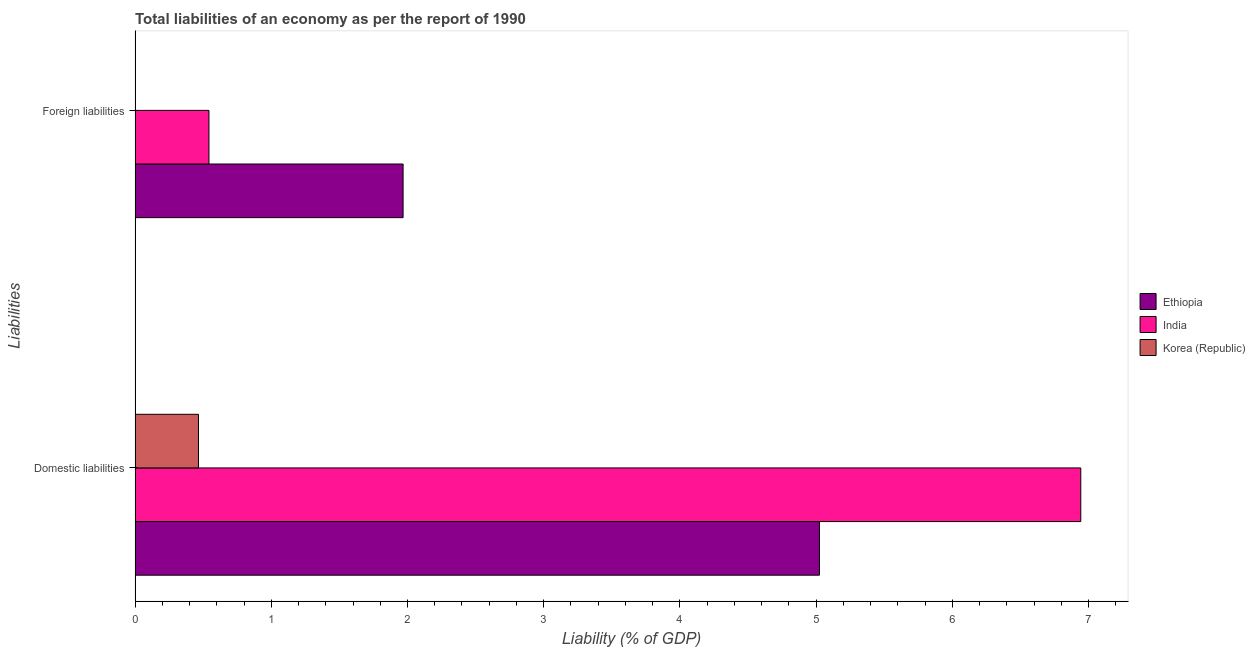How many different coloured bars are there?
Ensure brevity in your answer.  3. Are the number of bars per tick equal to the number of legend labels?
Provide a short and direct response. No. How many bars are there on the 2nd tick from the top?
Ensure brevity in your answer.  3. What is the label of the 1st group of bars from the top?
Keep it short and to the point. Foreign liabilities. What is the incurrence of domestic liabilities in Ethiopia?
Provide a succinct answer. 5.02. Across all countries, what is the maximum incurrence of foreign liabilities?
Make the answer very short. 1.97. In which country was the incurrence of foreign liabilities maximum?
Provide a succinct answer. Ethiopia. What is the total incurrence of domestic liabilities in the graph?
Provide a succinct answer. 12.43. What is the difference between the incurrence of domestic liabilities in Korea (Republic) and that in Ethiopia?
Your answer should be very brief. -4.56. What is the difference between the incurrence of foreign liabilities in Ethiopia and the incurrence of domestic liabilities in Korea (Republic)?
Offer a very short reply. 1.5. What is the average incurrence of domestic liabilities per country?
Ensure brevity in your answer.  4.14. What is the difference between the incurrence of foreign liabilities and incurrence of domestic liabilities in Ethiopia?
Give a very brief answer. -3.06. In how many countries, is the incurrence of domestic liabilities greater than 5.6 %?
Your answer should be very brief. 1. What is the ratio of the incurrence of domestic liabilities in Ethiopia to that in India?
Your answer should be compact. 0.72. How many bars are there?
Make the answer very short. 5. What is the difference between two consecutive major ticks on the X-axis?
Make the answer very short. 1. Are the values on the major ticks of X-axis written in scientific E-notation?
Give a very brief answer. No. Does the graph contain any zero values?
Provide a succinct answer. Yes. Where does the legend appear in the graph?
Ensure brevity in your answer.  Center right. How many legend labels are there?
Offer a very short reply. 3. How are the legend labels stacked?
Give a very brief answer. Vertical. What is the title of the graph?
Provide a short and direct response. Total liabilities of an economy as per the report of 1990. Does "New Caledonia" appear as one of the legend labels in the graph?
Offer a terse response. No. What is the label or title of the X-axis?
Keep it short and to the point. Liability (% of GDP). What is the label or title of the Y-axis?
Provide a succinct answer. Liabilities. What is the Liability (% of GDP) in Ethiopia in Domestic liabilities?
Provide a succinct answer. 5.02. What is the Liability (% of GDP) of India in Domestic liabilities?
Provide a short and direct response. 6.94. What is the Liability (% of GDP) in Korea (Republic) in Domestic liabilities?
Provide a succinct answer. 0.47. What is the Liability (% of GDP) in Ethiopia in Foreign liabilities?
Provide a short and direct response. 1.97. What is the Liability (% of GDP) of India in Foreign liabilities?
Give a very brief answer. 0.54. What is the Liability (% of GDP) in Korea (Republic) in Foreign liabilities?
Offer a very short reply. 0. Across all Liabilities, what is the maximum Liability (% of GDP) of Ethiopia?
Your answer should be compact. 5.02. Across all Liabilities, what is the maximum Liability (% of GDP) in India?
Your response must be concise. 6.94. Across all Liabilities, what is the maximum Liability (% of GDP) of Korea (Republic)?
Your answer should be very brief. 0.47. Across all Liabilities, what is the minimum Liability (% of GDP) of Ethiopia?
Ensure brevity in your answer.  1.97. Across all Liabilities, what is the minimum Liability (% of GDP) of India?
Your answer should be very brief. 0.54. What is the total Liability (% of GDP) of Ethiopia in the graph?
Make the answer very short. 6.99. What is the total Liability (% of GDP) in India in the graph?
Give a very brief answer. 7.49. What is the total Liability (% of GDP) in Korea (Republic) in the graph?
Provide a short and direct response. 0.47. What is the difference between the Liability (% of GDP) of Ethiopia in Domestic liabilities and that in Foreign liabilities?
Provide a short and direct response. 3.06. What is the difference between the Liability (% of GDP) of India in Domestic liabilities and that in Foreign liabilities?
Keep it short and to the point. 6.4. What is the difference between the Liability (% of GDP) of Ethiopia in Domestic liabilities and the Liability (% of GDP) of India in Foreign liabilities?
Offer a terse response. 4.48. What is the average Liability (% of GDP) in Ethiopia per Liabilities?
Your answer should be very brief. 3.5. What is the average Liability (% of GDP) in India per Liabilities?
Ensure brevity in your answer.  3.74. What is the average Liability (% of GDP) of Korea (Republic) per Liabilities?
Keep it short and to the point. 0.23. What is the difference between the Liability (% of GDP) of Ethiopia and Liability (% of GDP) of India in Domestic liabilities?
Give a very brief answer. -1.92. What is the difference between the Liability (% of GDP) in Ethiopia and Liability (% of GDP) in Korea (Republic) in Domestic liabilities?
Provide a succinct answer. 4.56. What is the difference between the Liability (% of GDP) of India and Liability (% of GDP) of Korea (Republic) in Domestic liabilities?
Your answer should be compact. 6.48. What is the difference between the Liability (% of GDP) in Ethiopia and Liability (% of GDP) in India in Foreign liabilities?
Make the answer very short. 1.43. What is the ratio of the Liability (% of GDP) of Ethiopia in Domestic liabilities to that in Foreign liabilities?
Your answer should be compact. 2.55. What is the ratio of the Liability (% of GDP) of India in Domestic liabilities to that in Foreign liabilities?
Your response must be concise. 12.8. What is the difference between the highest and the second highest Liability (% of GDP) of Ethiopia?
Provide a succinct answer. 3.06. What is the difference between the highest and the second highest Liability (% of GDP) of India?
Provide a succinct answer. 6.4. What is the difference between the highest and the lowest Liability (% of GDP) of Ethiopia?
Offer a very short reply. 3.06. What is the difference between the highest and the lowest Liability (% of GDP) in India?
Your answer should be very brief. 6.4. What is the difference between the highest and the lowest Liability (% of GDP) of Korea (Republic)?
Your answer should be very brief. 0.47. 